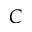<formula> <loc_0><loc_0><loc_500><loc_500>C</formula> 